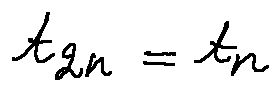<formula> <loc_0><loc_0><loc_500><loc_500>t _ { 2 n } = t _ { n }</formula> 